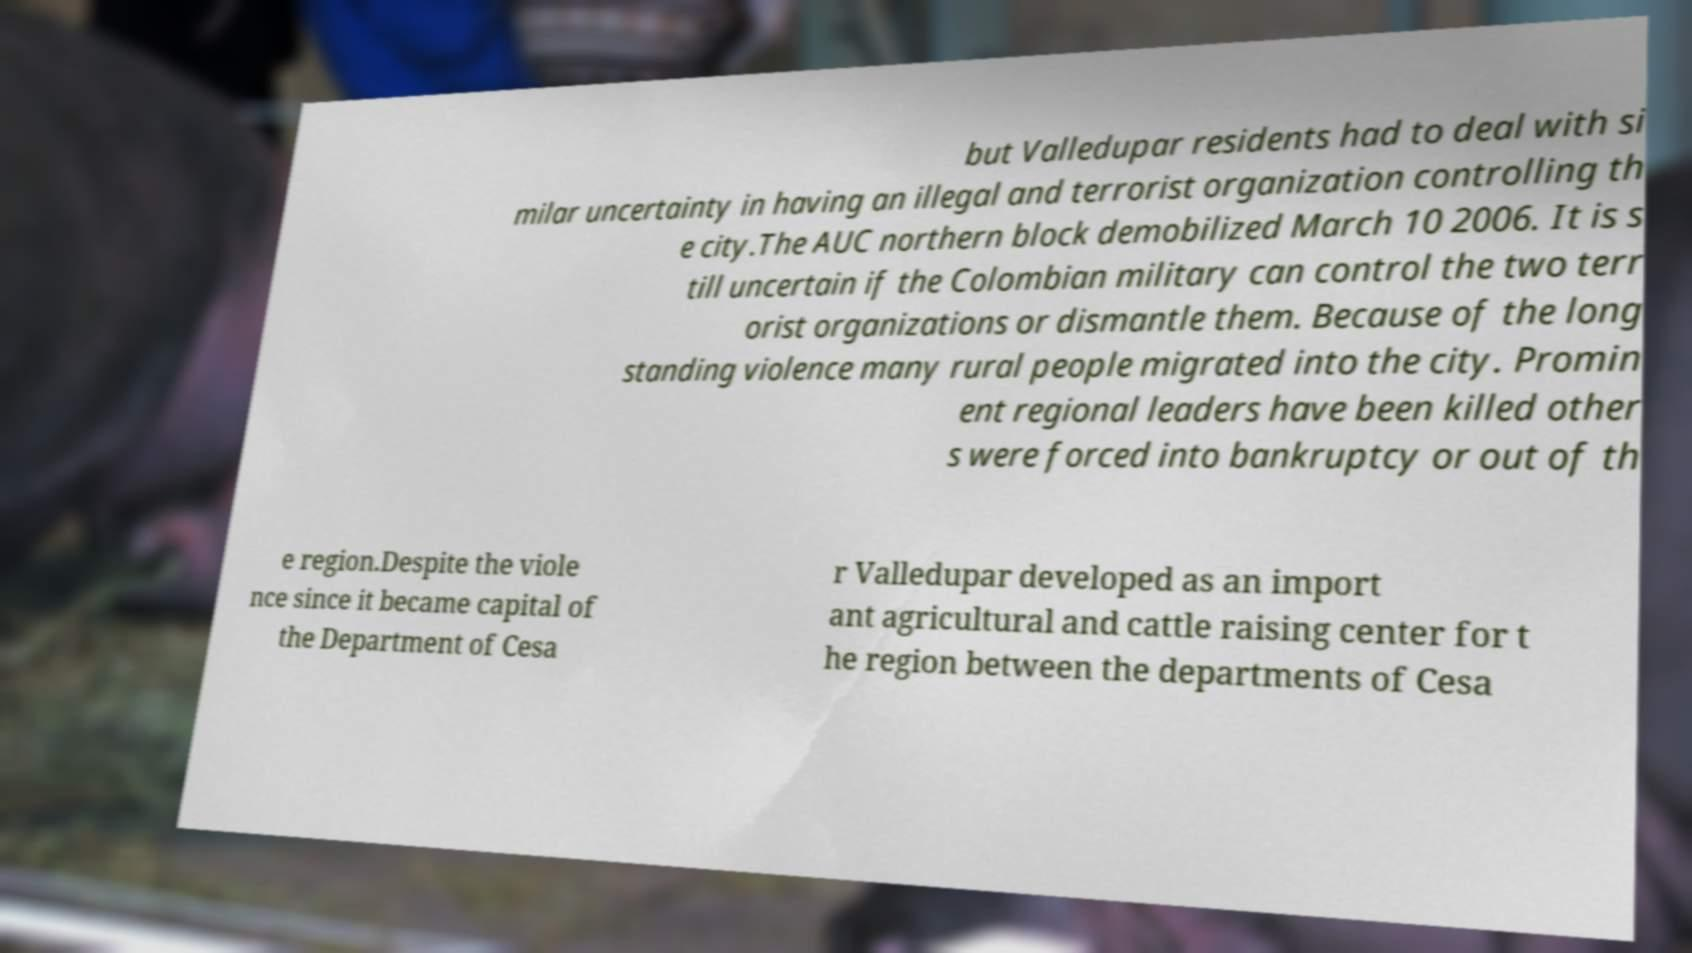Could you extract and type out the text from this image? but Valledupar residents had to deal with si milar uncertainty in having an illegal and terrorist organization controlling th e city.The AUC northern block demobilized March 10 2006. It is s till uncertain if the Colombian military can control the two terr orist organizations or dismantle them. Because of the long standing violence many rural people migrated into the city. Promin ent regional leaders have been killed other s were forced into bankruptcy or out of th e region.Despite the viole nce since it became capital of the Department of Cesa r Valledupar developed as an import ant agricultural and cattle raising center for t he region between the departments of Cesa 